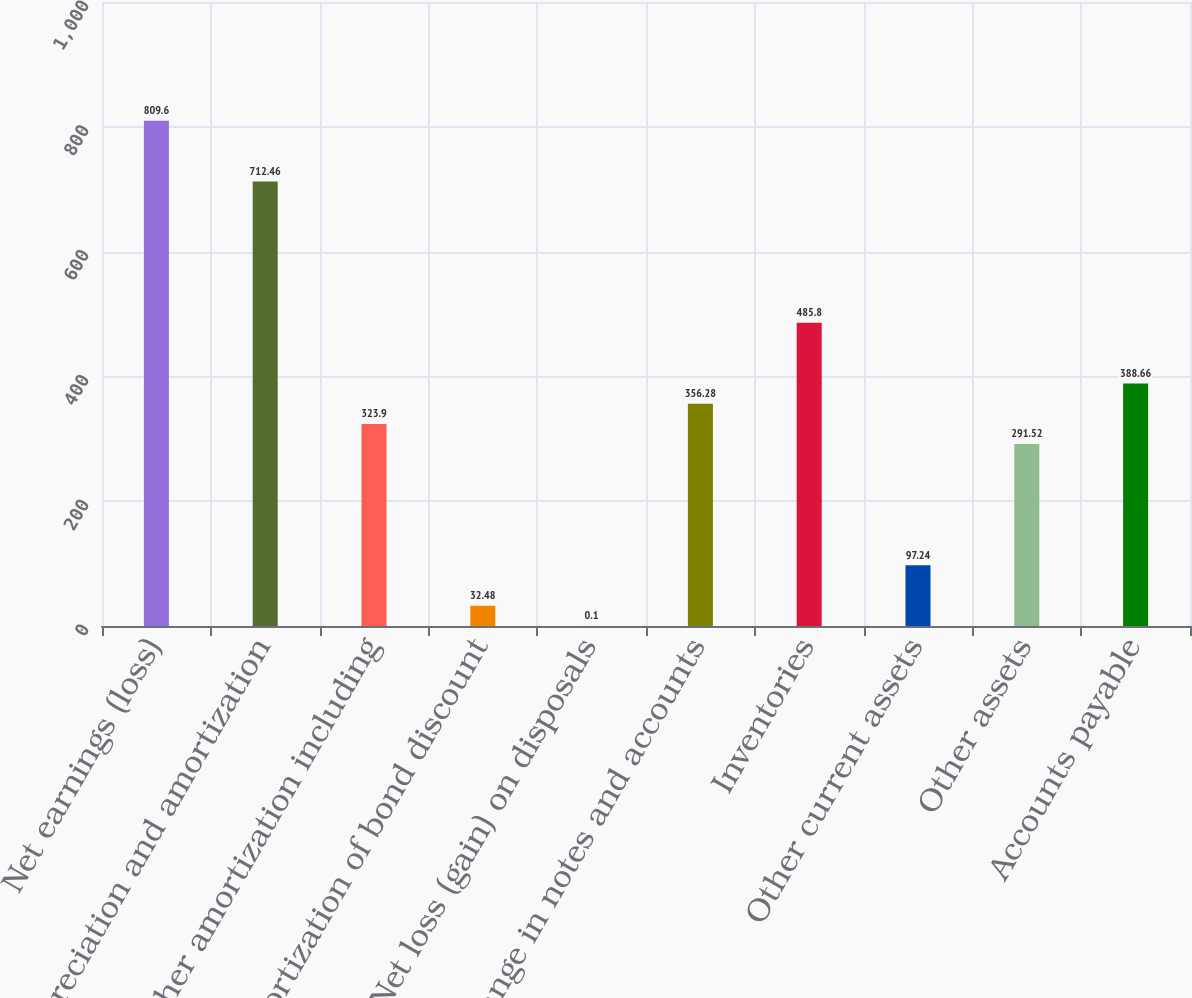<chart> <loc_0><loc_0><loc_500><loc_500><bar_chart><fcel>Net earnings (loss)<fcel>Depreciation and amortization<fcel>Other amortization including<fcel>Amortization of bond discount<fcel>Net loss (gain) on disposals<fcel>Change in notes and accounts<fcel>Inventories<fcel>Other current assets<fcel>Other assets<fcel>Accounts payable<nl><fcel>809.6<fcel>712.46<fcel>323.9<fcel>32.48<fcel>0.1<fcel>356.28<fcel>485.8<fcel>97.24<fcel>291.52<fcel>388.66<nl></chart> 